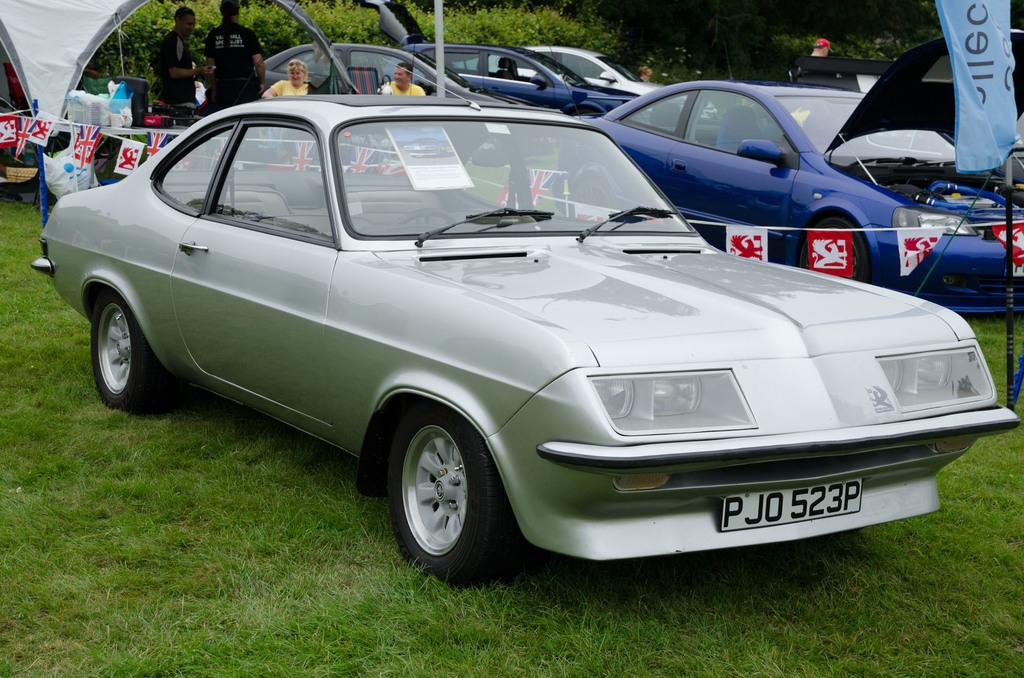What types of objects are on the ground in the image? There are vehicles on the ground in the image. What can be seen in the background of the image? There is grass, poles, and flags visible in the background of the image. What are the people in the image doing? People are standing on the ground in the image. Can you tell me how many cribs are visible in the image? There are no cribs present in the image. What type of whip is being used by the people in the image? There is no whip present in the image; people are simply standing on the ground. 